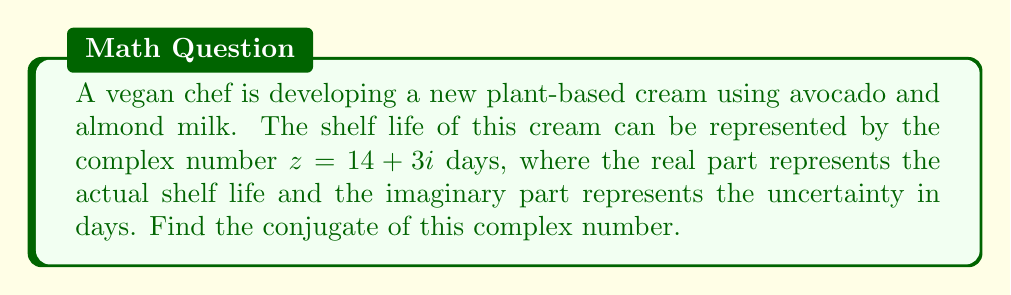Teach me how to tackle this problem. To find the conjugate of a complex number, we follow these steps:

1. Recall that for a complex number $z = a + bi$, its conjugate is denoted as $\bar{z}$ or $z^*$ and is equal to $a - bi$.

2. In this case, we have $z = 14 + 3i$, where:
   $a = 14$ (the real part)
   $b = 3$ (the coefficient of the imaginary part)

3. To find the conjugate, we keep the real part the same and change the sign of the imaginary part:

   $\bar{z} = 14 - 3i$

This conjugate represents a shelf life of 14 days with an uncertainty of 3 days in the opposite direction.
Answer: $14 - 3i$ 